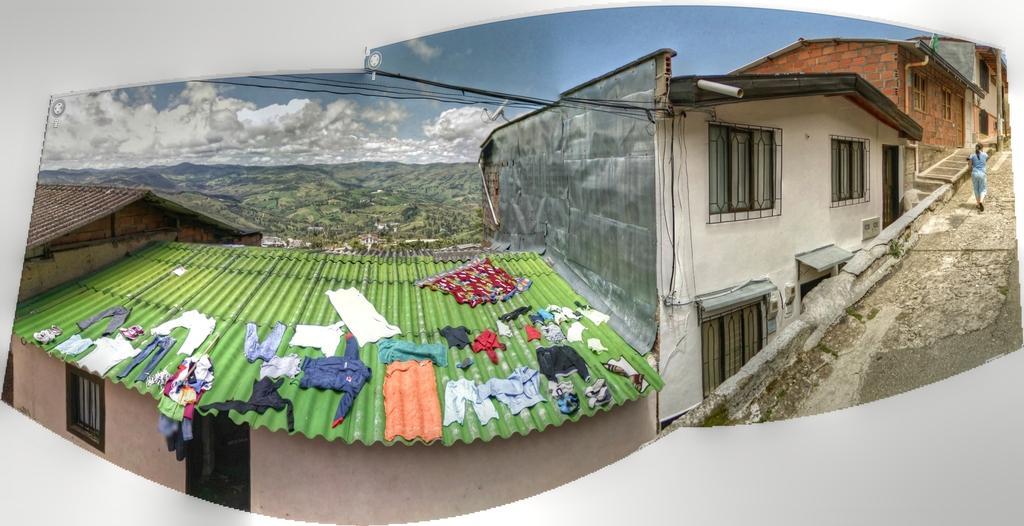Can you describe this image briefly? I can see this is an edited image. There is a person walking on the road. There are buildings, clothes, cables, trees, hills, and in the background there is sky. 